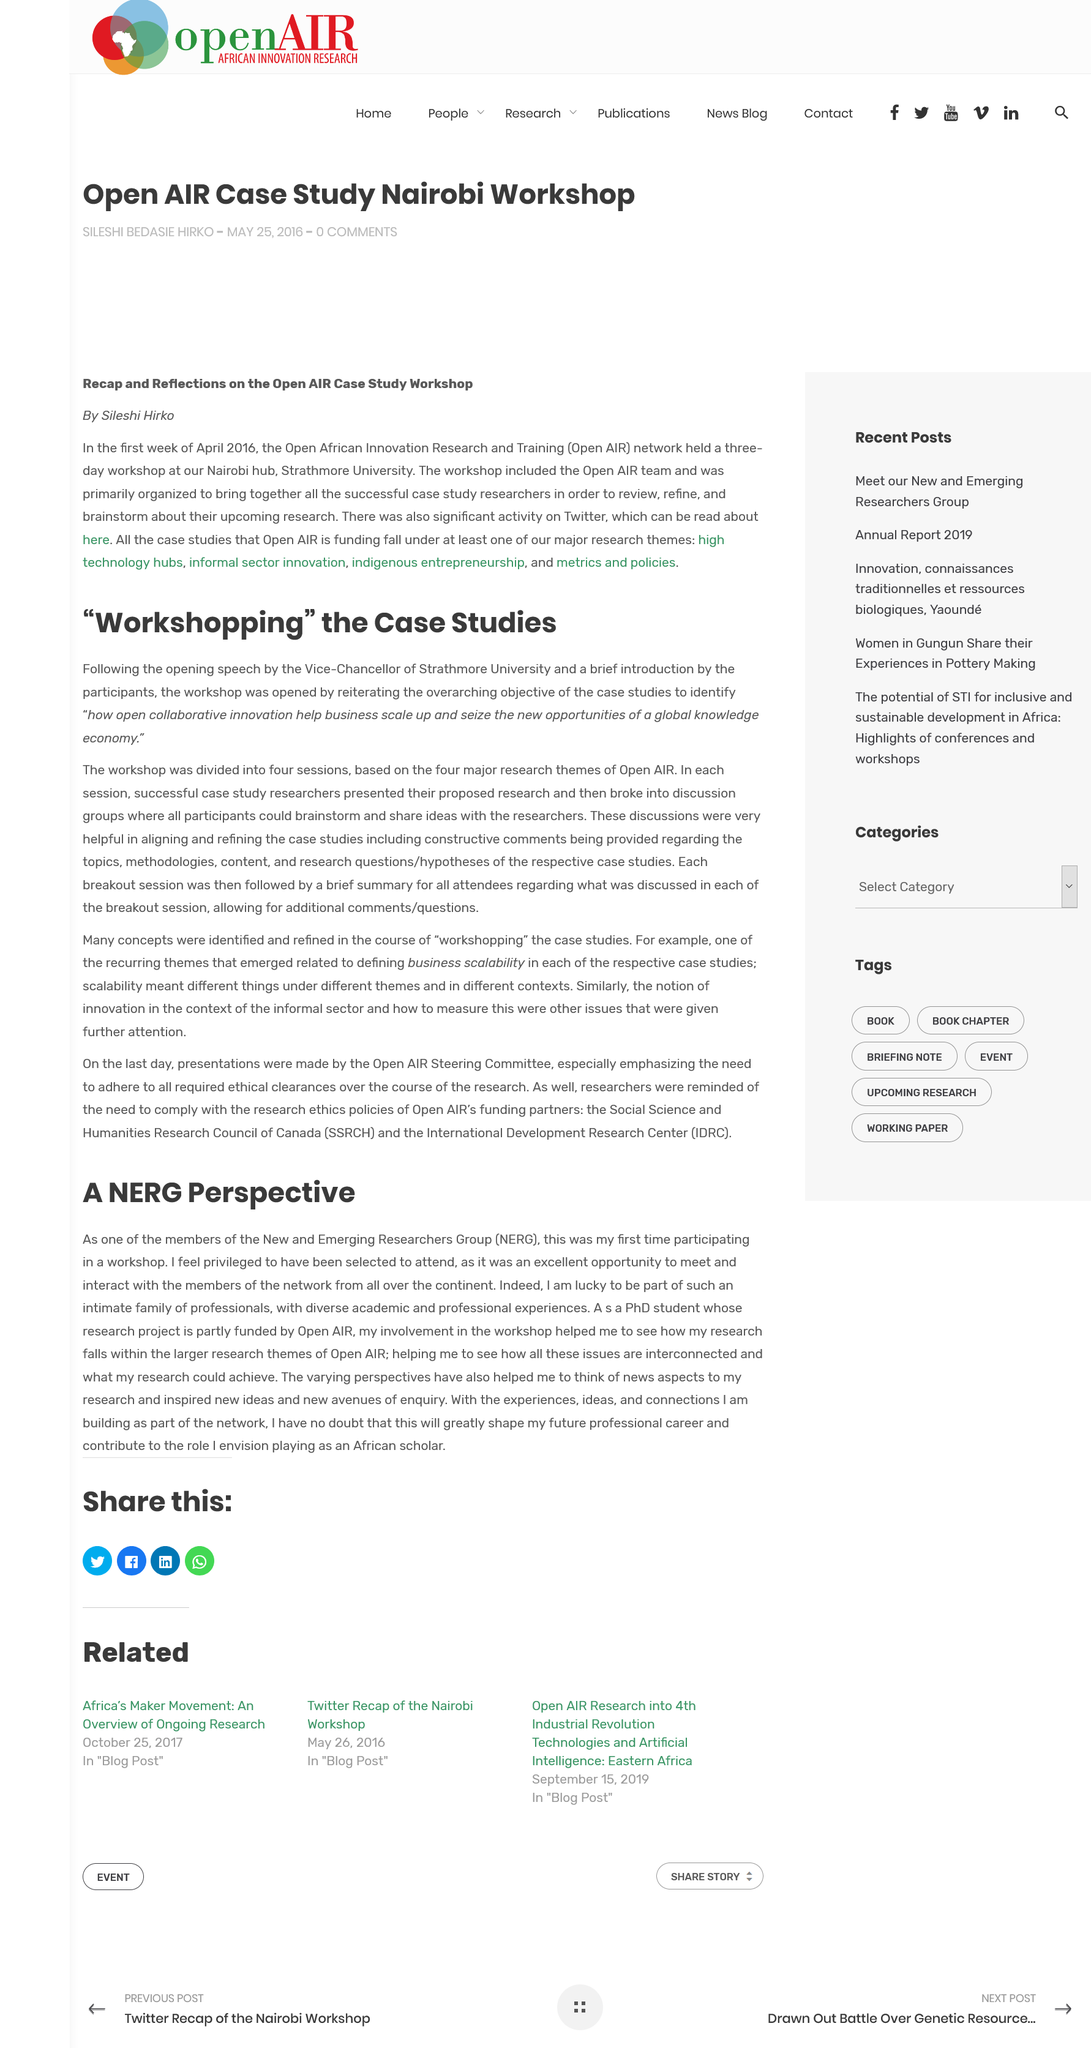Identify some key points in this picture. The research project of the person is partially funded by Open AIR. NERG stands for New and Emerging Researchers Group. The author is currently pursuing a PhD in a relevant field. 